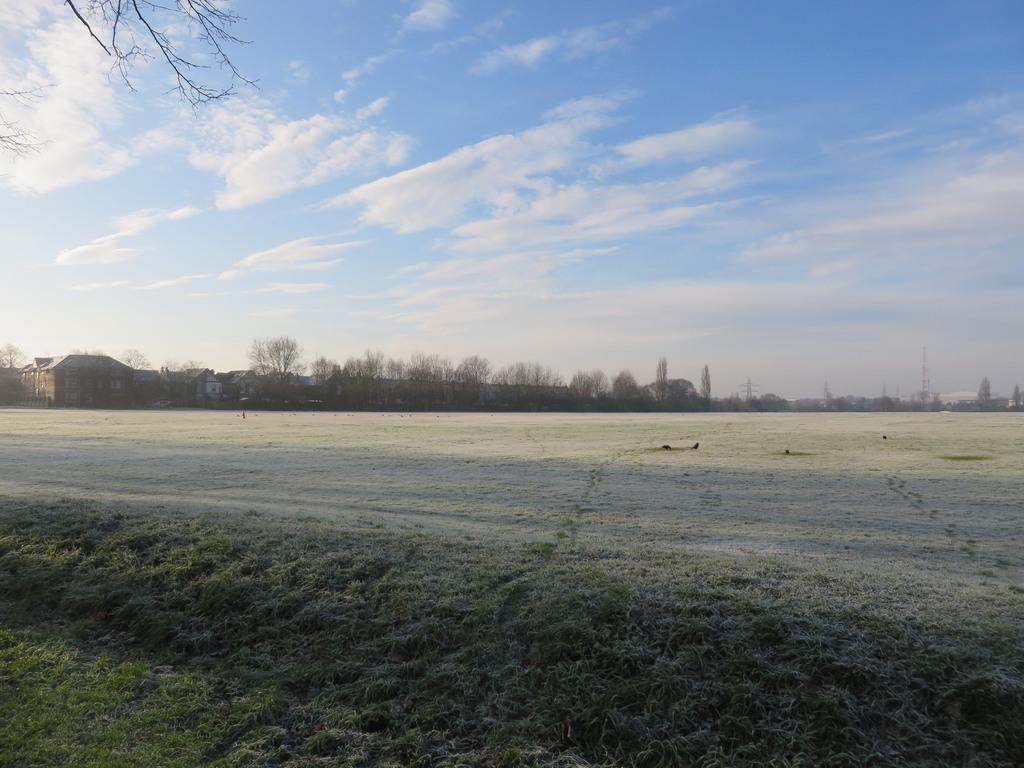What type of vegetation is visible in the image? There is grass in the image. What type of structures can be seen in the image? There are buildings in the image. What other natural elements are present in the image? There are trees in the image. What is visible in the sky in the image? There are clouds in the sky in the image. What shape is the rod used for printing in the image? There is no rod or printing activity present in the image. What type of print can be seen on the grass in the image? There is no print or any indication of printing activity on the grass in the image. 